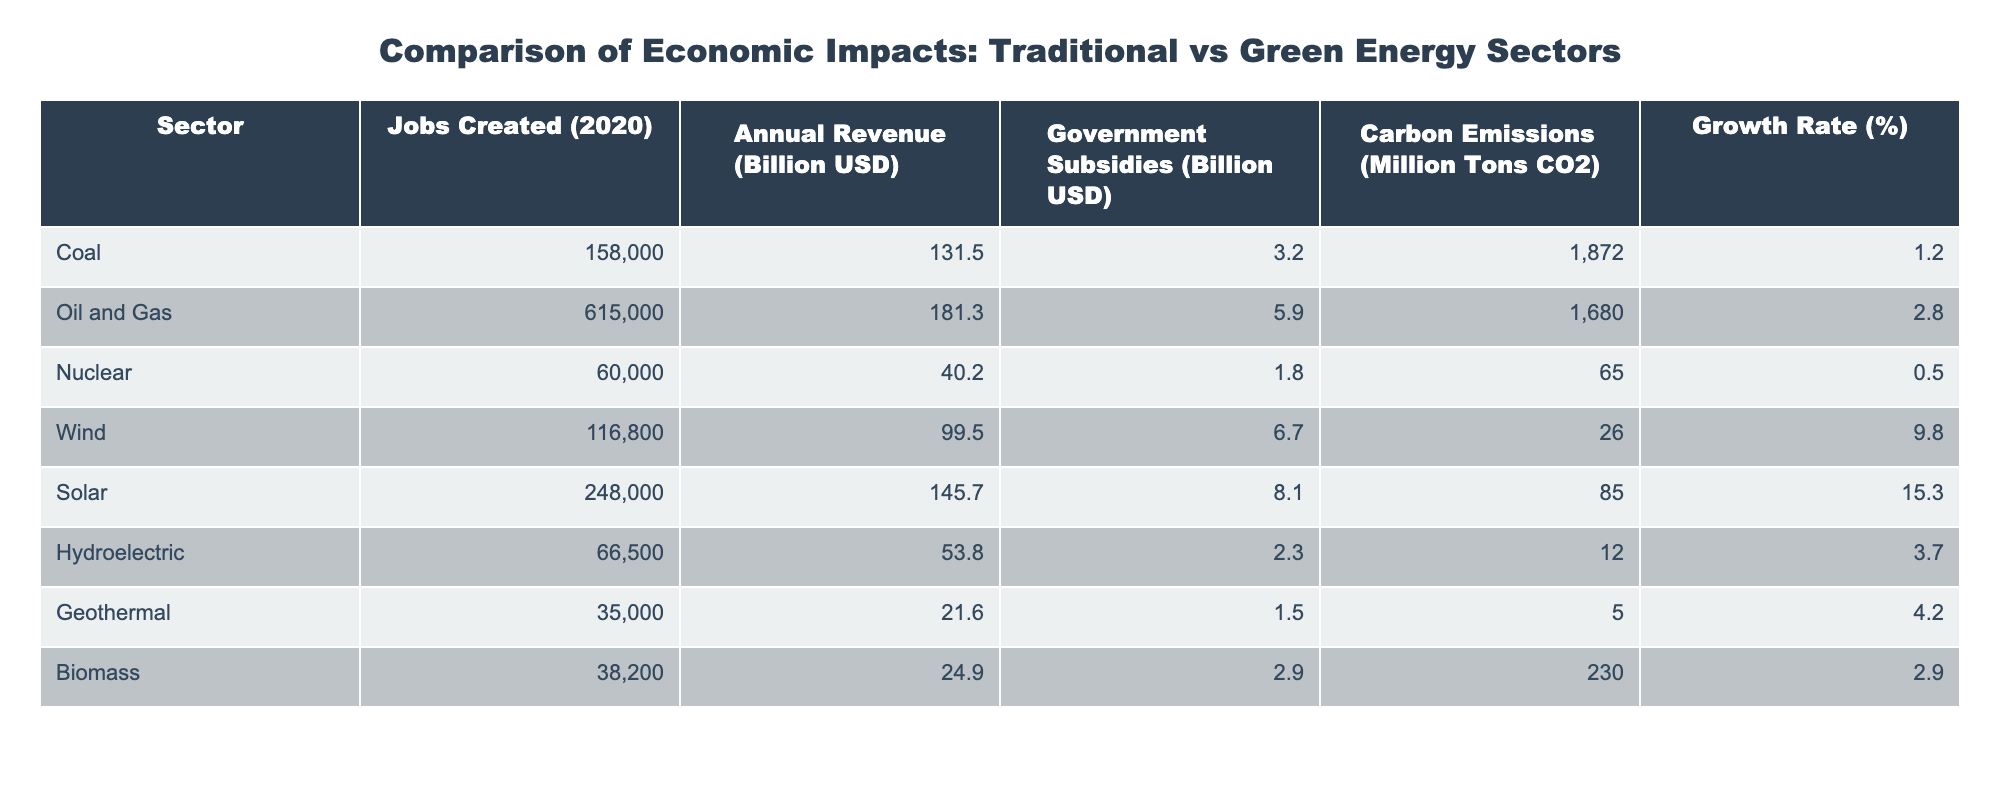What sector created the most jobs in 2020? The "Jobs Created (2020)" column shows that the Oil and Gas sector created 615,000 jobs, which is the highest number among all sectors listed.
Answer: Oil and Gas What is the annual revenue for the Solar energy sector? The "Annual Revenue (Billion USD)" column indicates that the Solar energy sector generated 145.7 billion USD in revenue.
Answer: 145.7 billion USD Which sector received the highest government subsidies? The "Government Subsidies (Billion USD)" column indicates that the Solar sector received 8.1 billion USD, which is more than any other sector.
Answer: Solar What is the difference in carbon emissions between Coal and Hydroelectric sectors? Coal has 1,872 million tons CO2 and Hydroelectric has 12 million tons CO2. The difference is 1,872 - 12 = 1,860 million tons CO2.
Answer: 1,860 million tons CO2 Which green energy sector has the highest growth rate? The "Growth Rate (%)" column shows the Solar sector has a growth rate of 15.3%, which is higher than other sectors.
Answer: Solar Is it true that Nuclear energy has the lowest carbon emissions? Yes, the "Carbon Emissions (Million Tons CO2)" column reveals that Nuclear energy has 65 million tons CO2, which is indeed the lowest among all sectors listed.
Answer: Yes How does the annual revenue of Wind energy compare to that of Biomass energy? Wind energy has 99.5 billion USD and Biomass has 24.9 billion USD. The difference is 99.5 - 24.9 = 74.6 billion USD, indicating that Wind energy earns significantly more.
Answer: Wind earns 74.6 billion USD more What is the average number of jobs created across all sectors? To find the average, sum the jobs created for all sectors (158,000 + 615,000 + 60,000 + 116,800 + 248,000 + 66,500 + 35,000 + 38,200) = 1,338,500. There are 8 sectors, so the average is 1,338,500 / 8 = 167,312.5, which rounds to 167,313.
Answer: 167,313 Which traditional energy sector has a higher growth rate than Hydroelectric? The growth rates for Coal (1.2%), Oil and Gas (2.8%), and Nuclear (0.5%) are all lower than Hydroelectric’s 3.7%, so none of the traditional sectors exceed Hydroelectric’s growth rate.
Answer: None What is the total carbon emissions from Wind and Solar sectors combined? Wind has 26 million tons CO2 and Solar has 85 million tons CO2. The total carbon emissions are 26 + 85 = 111 million tons CO2.
Answer: 111 million tons CO2 